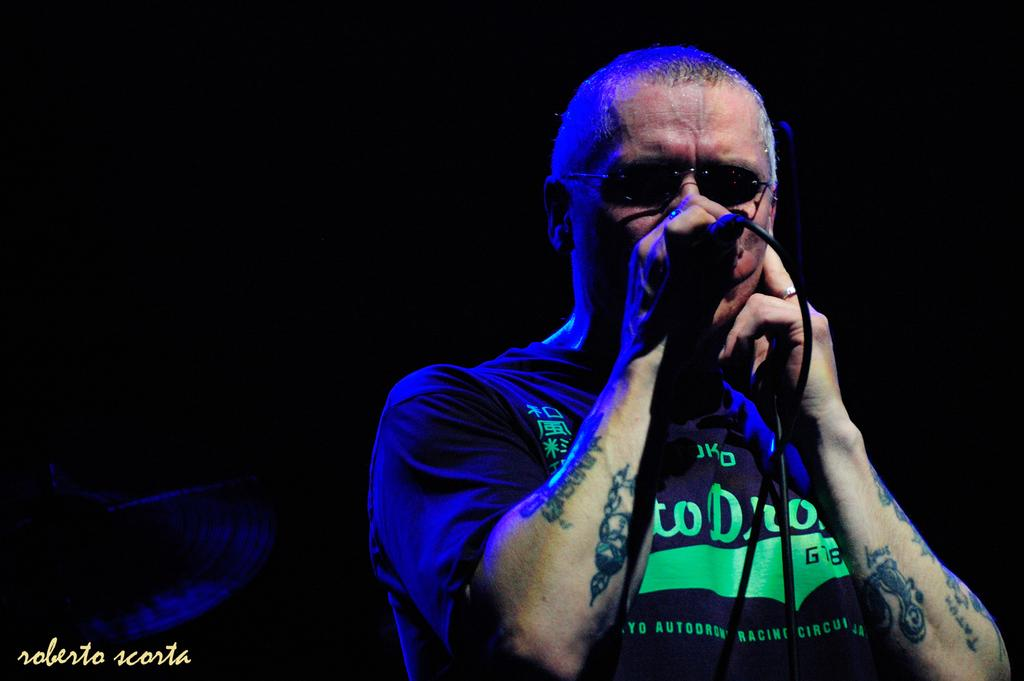What is the main subject of the image? There is a person in the image. What is the person holding in the image? The person is holding a mic. Can you describe the background of the image? The background of the image is dark. How many books can be seen in the image? There are no books present in the image. What type of impulse can be seen affecting the person in the image? There is no impulse affecting the person in the image; they are simply holding a mic. 